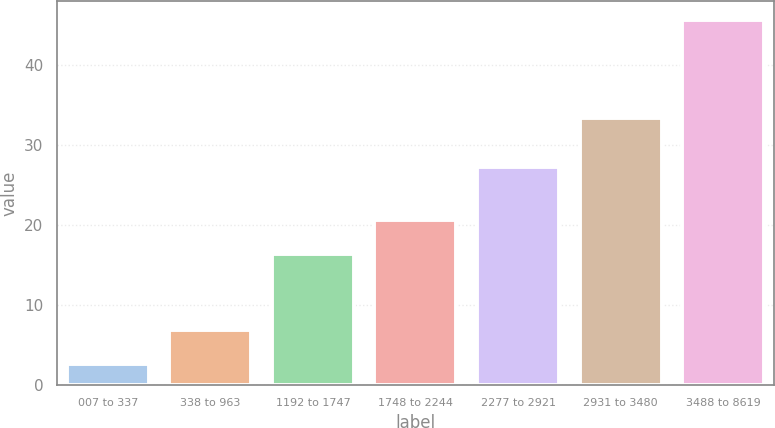<chart> <loc_0><loc_0><loc_500><loc_500><bar_chart><fcel>007 to 337<fcel>338 to 963<fcel>1192 to 1747<fcel>1748 to 2244<fcel>2277 to 2921<fcel>2931 to 3480<fcel>3488 to 8619<nl><fcel>2.59<fcel>6.89<fcel>16.33<fcel>20.63<fcel>27.18<fcel>33.36<fcel>45.64<nl></chart> 